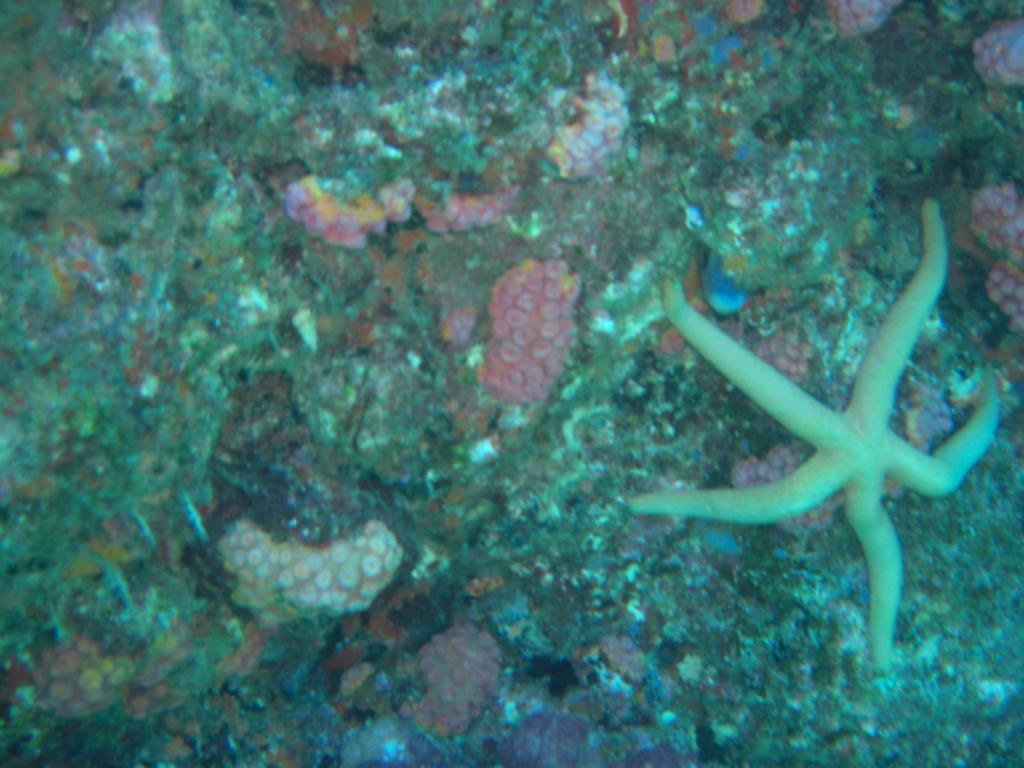What is the main subject of the image? The main subject of the image is a starfish. Where is the starfish located? The starfish is on an aquatic rock. How many gold balls are visible in the image? There are no gold balls present in the image; it features a starfish on an aquatic rock. What is the aftermath of the starfish's actions in the image? There is no indication of any actions taken by the starfish in the image, so it is not possible to determine the aftermath. 